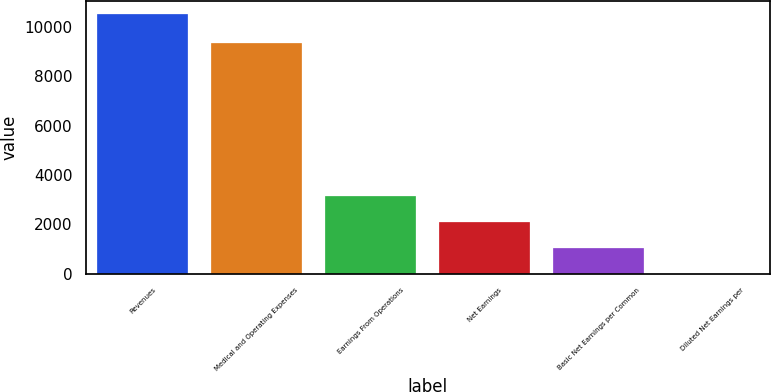<chart> <loc_0><loc_0><loc_500><loc_500><bar_chart><fcel>Revenues<fcel>Medical and Operating Expenses<fcel>Earnings From Operations<fcel>Net Earnings<fcel>Basic Net Earnings per Common<fcel>Diluted Net Earnings per<nl><fcel>10511<fcel>9323<fcel>3154.06<fcel>2103.07<fcel>1052.08<fcel>1.09<nl></chart> 